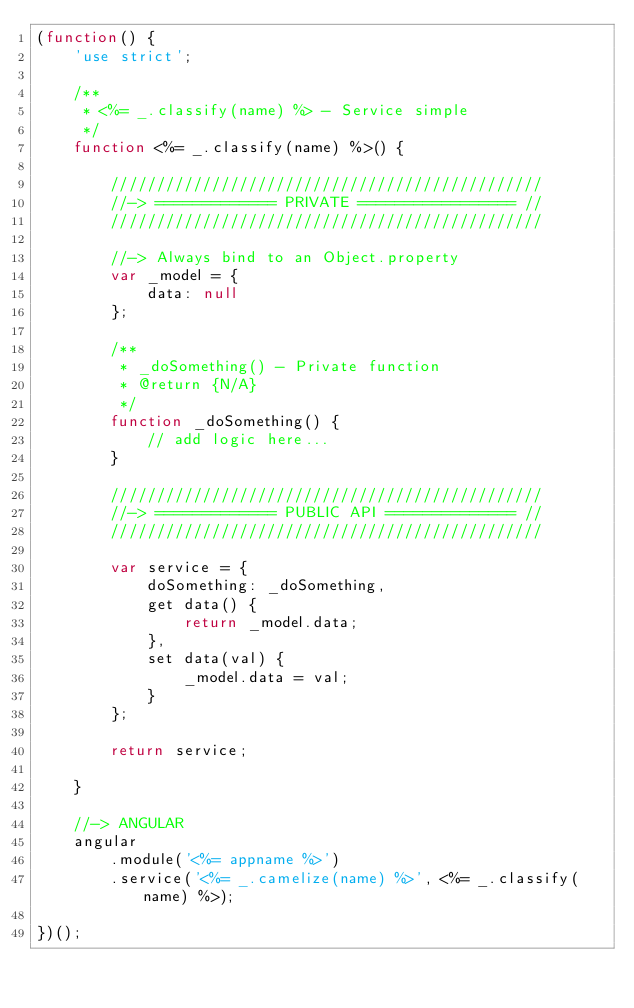Convert code to text. <code><loc_0><loc_0><loc_500><loc_500><_JavaScript_>(function() {
    'use strict';

    /**
     * <%= _.classify(name) %> - Service simple
     */
    function <%= _.classify(name) %>() {

        ///////////////////////////////////////////////
        //-> ============= PRIVATE ================= //
        ///////////////////////////////////////////////

        //-> Always bind to an Object.property
        var _model = {
            data: null
        };

        /**
         * _doSomething() - Private function
         * @return {N/A}
         */
        function _doSomething() {
            // add logic here...
        }

        ///////////////////////////////////////////////
        //-> ============= PUBLIC API ============== //
        ///////////////////////////////////////////////

        var service = {
            doSomething: _doSomething,
            get data() {
                return _model.data;
            },
            set data(val) {
                _model.data = val;
            }
        };

        return service;

    }

    //-> ANGULAR
    angular
        .module('<%= appname %>')
        .service('<%= _.camelize(name) %>', <%= _.classify(name) %>);

})();</code> 